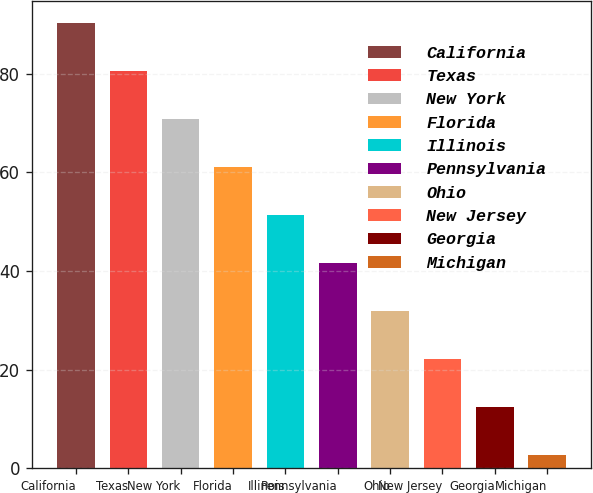Convert chart. <chart><loc_0><loc_0><loc_500><loc_500><bar_chart><fcel>California<fcel>Texas<fcel>New York<fcel>Florida<fcel>Illinois<fcel>Pennsylvania<fcel>Ohio<fcel>New Jersey<fcel>Georgia<fcel>Michigan<nl><fcel>90.28<fcel>80.56<fcel>70.84<fcel>61.12<fcel>51.4<fcel>41.68<fcel>31.96<fcel>22.24<fcel>12.52<fcel>2.8<nl></chart> 